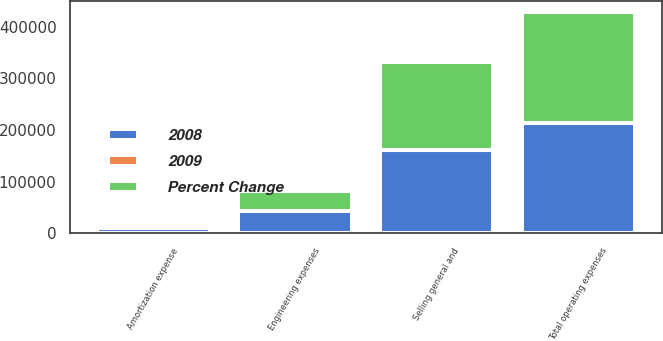<chart> <loc_0><loc_0><loc_500><loc_500><stacked_bar_chart><ecel><fcel>Selling general and<fcel>Engineering expenses<fcel>Amortization expense<fcel>Total operating expenses<nl><fcel>2008<fcel>160998<fcel>42447<fcel>9849<fcel>213294<nl><fcel>Percent Change<fcel>170597<fcel>38981<fcel>5092<fcel>214670<nl><fcel>2009<fcel>5.6<fcel>8.9<fcel>93.4<fcel>0.6<nl></chart> 